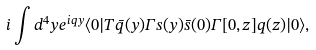Convert formula to latex. <formula><loc_0><loc_0><loc_500><loc_500>i \int d ^ { 4 } y e ^ { i q y } \langle 0 | T \bar { q } ( y ) \Gamma s ( y ) \bar { s } ( 0 ) \Gamma [ 0 , z ] q ( z ) | 0 \rangle ,</formula> 